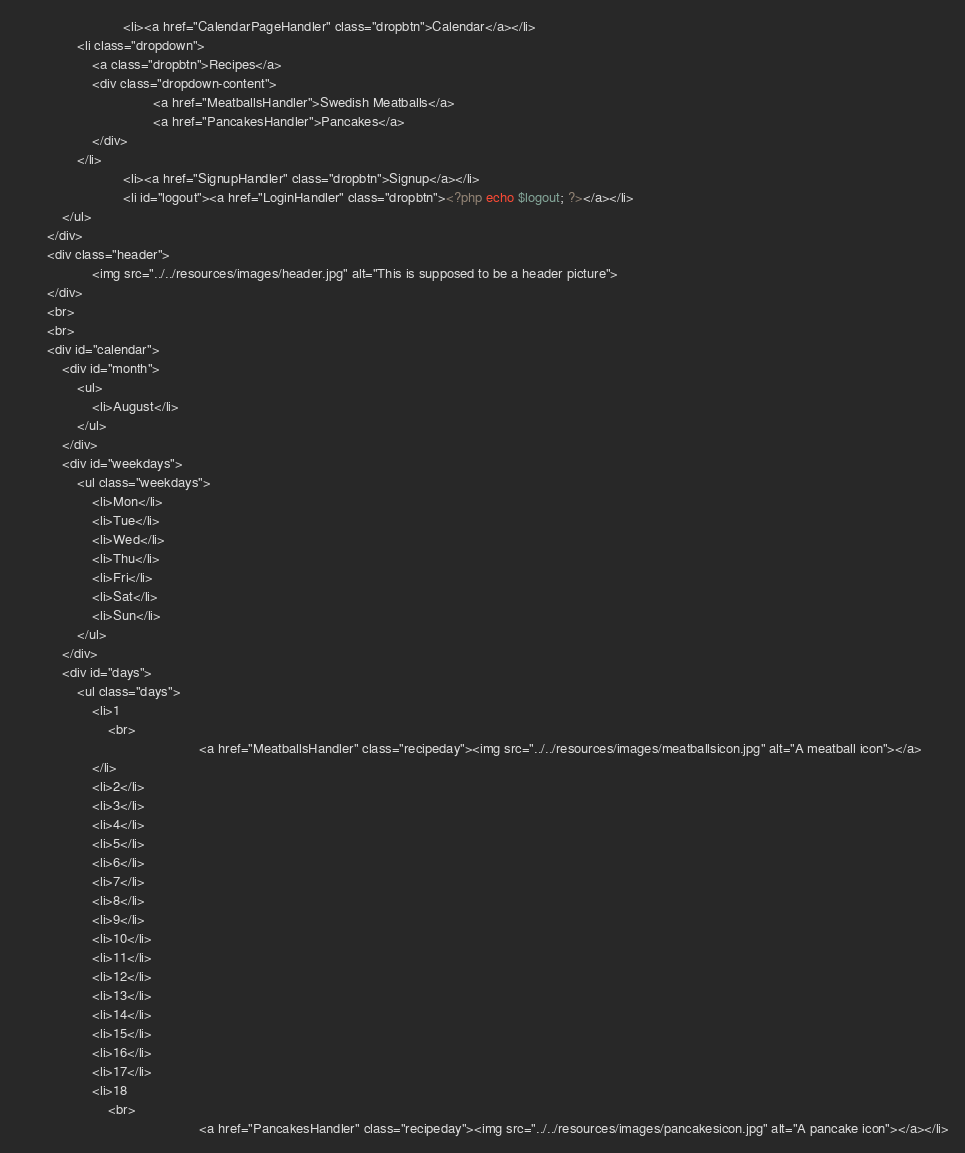Convert code to text. <code><loc_0><loc_0><loc_500><loc_500><_PHP_>                            <li><a href="CalendarPageHandler" class="dropbtn">Calendar</a></li>                            
  				<li class="dropdown">
    				<a class="dropbtn">Recipes</a>
    				<div class="dropdown-content">
                                    <a href="MeatballsHandler">Swedish Meatballs</a>
                                    <a href="PancakesHandler">Pancakes</a>
    				</div>
  				</li>
                            <li><a href="SignupHandler" class="dropbtn">Signup</a></li>
                            <li id="logout"><a href="LoginHandler" class="dropbtn"><?php echo $logout; ?></a></li>
			</ul>
		</div>
		<div class="header">
                    <img src="../../resources/images/header.jpg" alt="This is supposed to be a header picture">
		</div>
		<br>
		<br>
		<div id="calendar">
			<div id="month">
  				<ul>
    				<li>August</li>
  				</ul>
			</div>
			<div id="weekdays">
				<ul class="weekdays">
  					<li>Mon</li>
  					<li>Tue</li>
					<li>Wed</li>
					<li>Thu</li>
					<li>Fri</li>
					<li>Sat</li>
					<li>Sun</li>
				</ul>
			</div>
			<div id="days">
				<ul class="days">
					<li>1
						<br>
                                                <a href="MeatballsHandler" class="recipeday"><img src="../../resources/images/meatballsicon.jpg" alt="A meatball icon"></a>
					</li>
					<li>2</li>
					<li>3</li>
					<li>4</li>
					<li>5</li>
					<li>6</li>
					<li>7</li>
					<li>8</li>
					<li>9</li>
  					<li>10</li>
  					<li>11</li>
  					<li>12</li>
					<li>13</li>
					<li>14</li>
					<li>15</li>
					<li>16</li>
					<li>17</li>
					<li>18
						<br>
                                                <a href="PancakesHandler" class="recipeday"><img src="../../resources/images/pancakesicon.jpg" alt="A pancake icon"></a></li></code> 